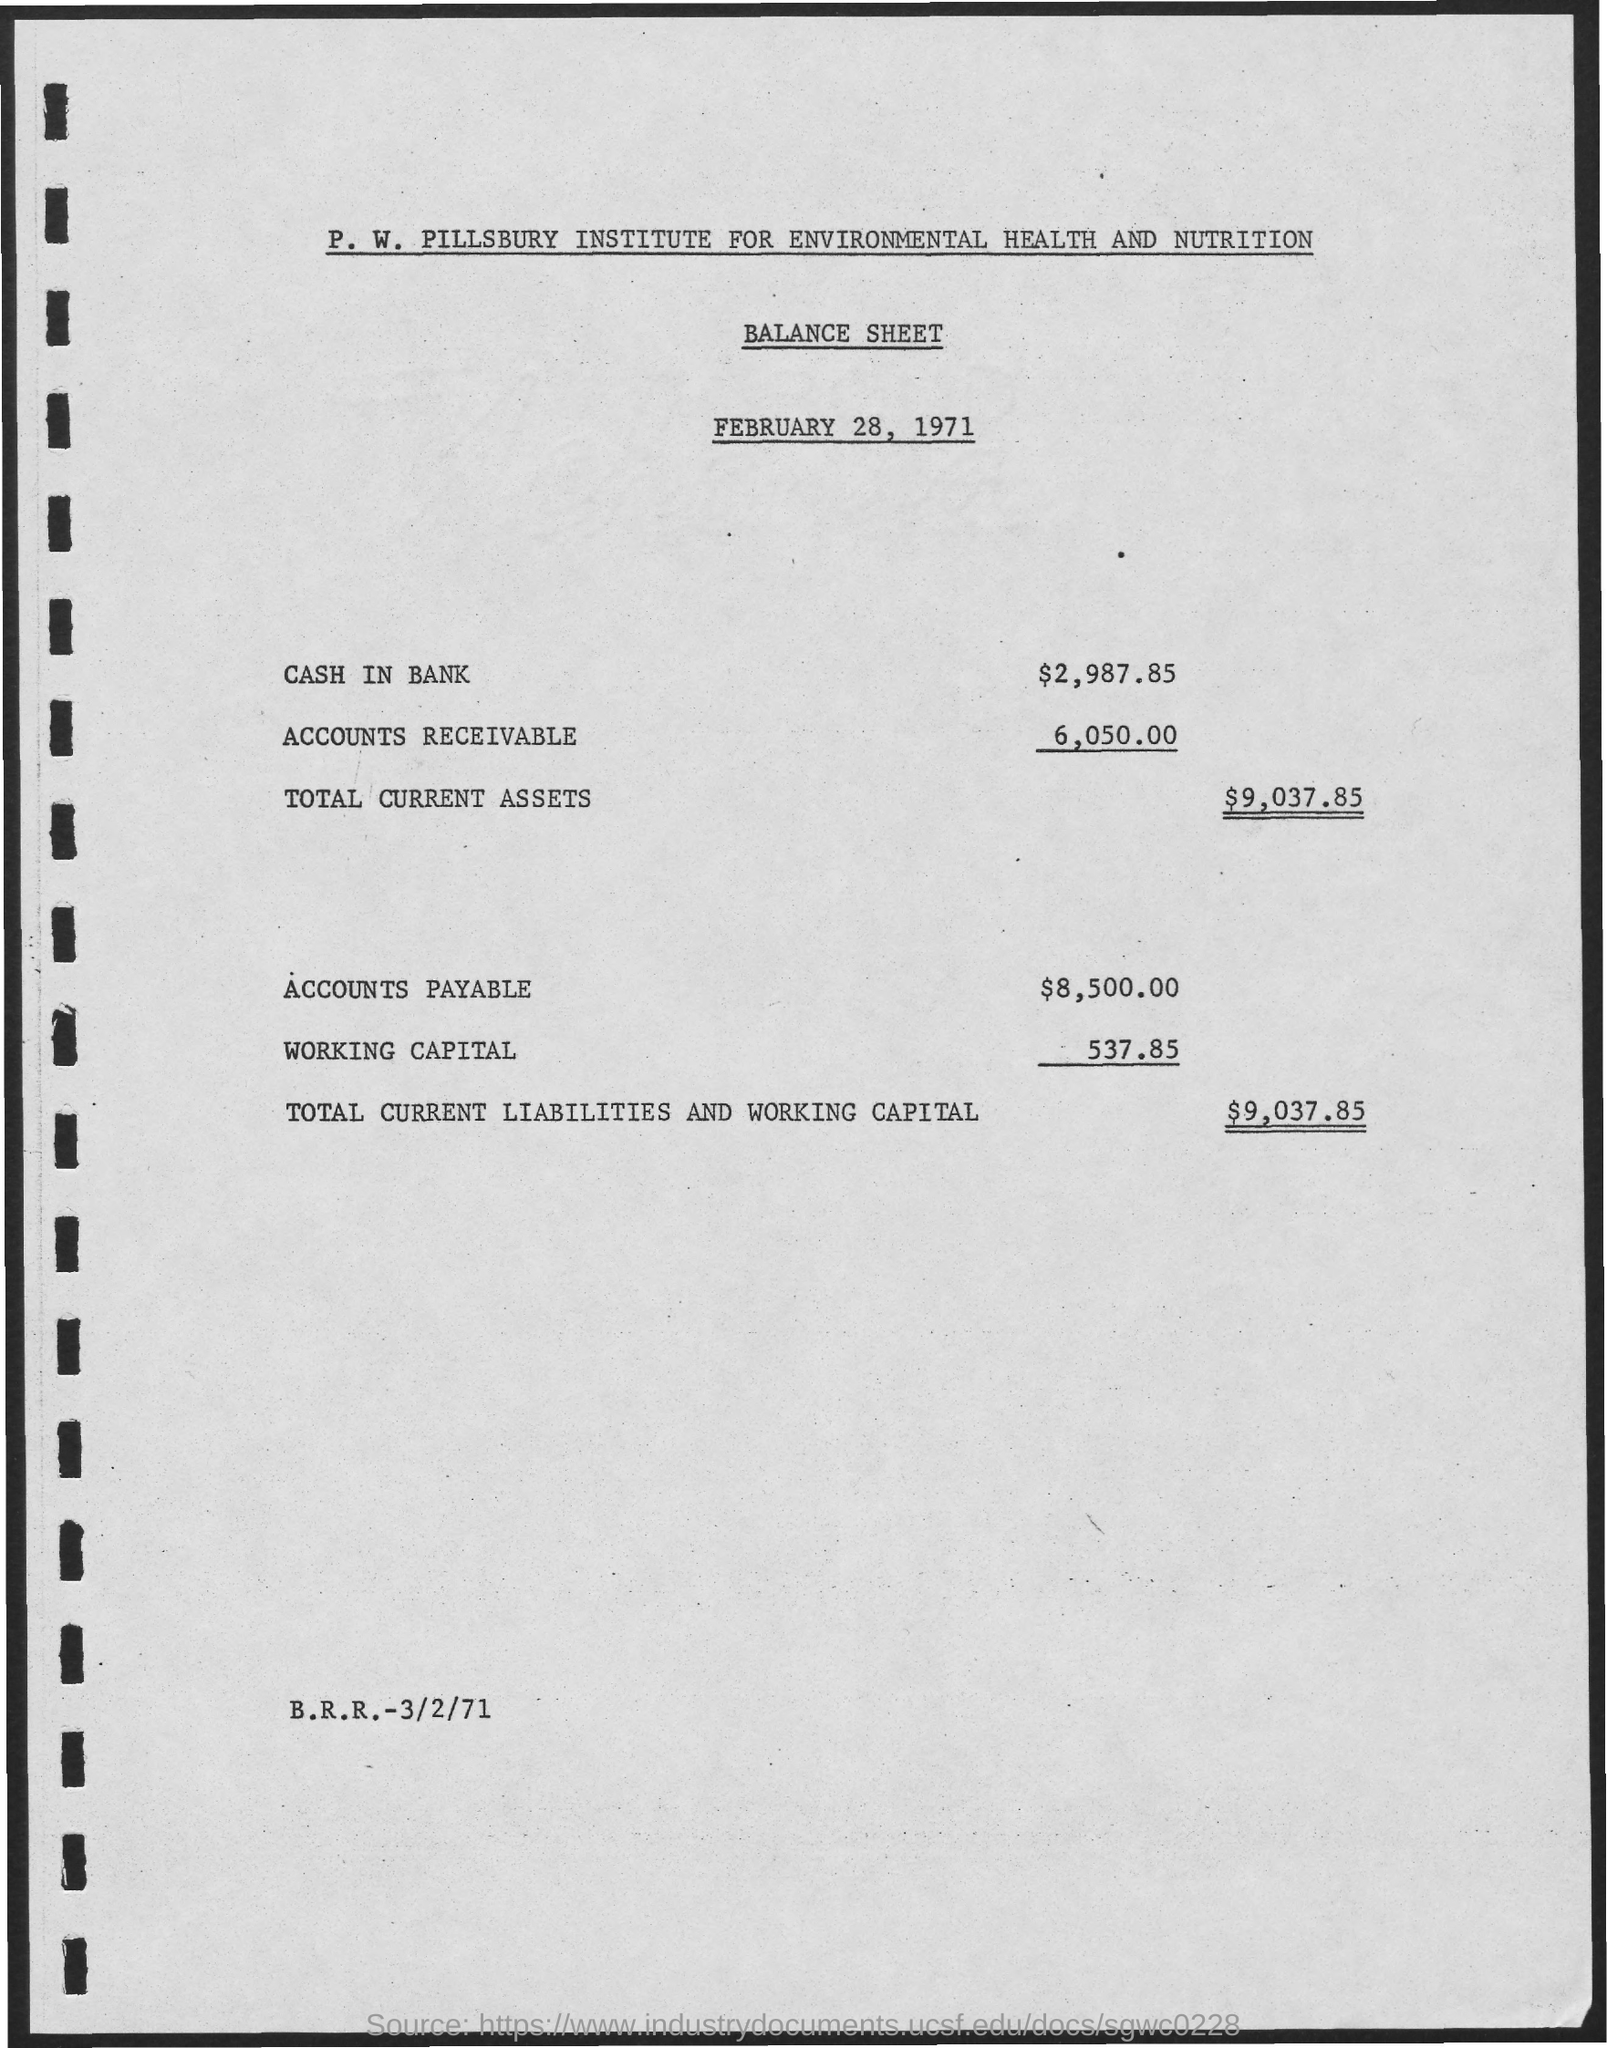Draw attention to some important aspects in this diagram. The amount mentioned for accounts receivable in the given balance sheet is 6,050.00. The total amount of current assets mentioned in the given balance sheet is $9,037.85. The total current liabilities and working capital mentioned in the given balance sheet are $9,037.85. The cash in bank account listed in the balance sheet is $2,987.85. The P.W. Pillsbury Institute for Environmental Health and Nutrition is the name of the institute mentioned in the given balance sheet. 